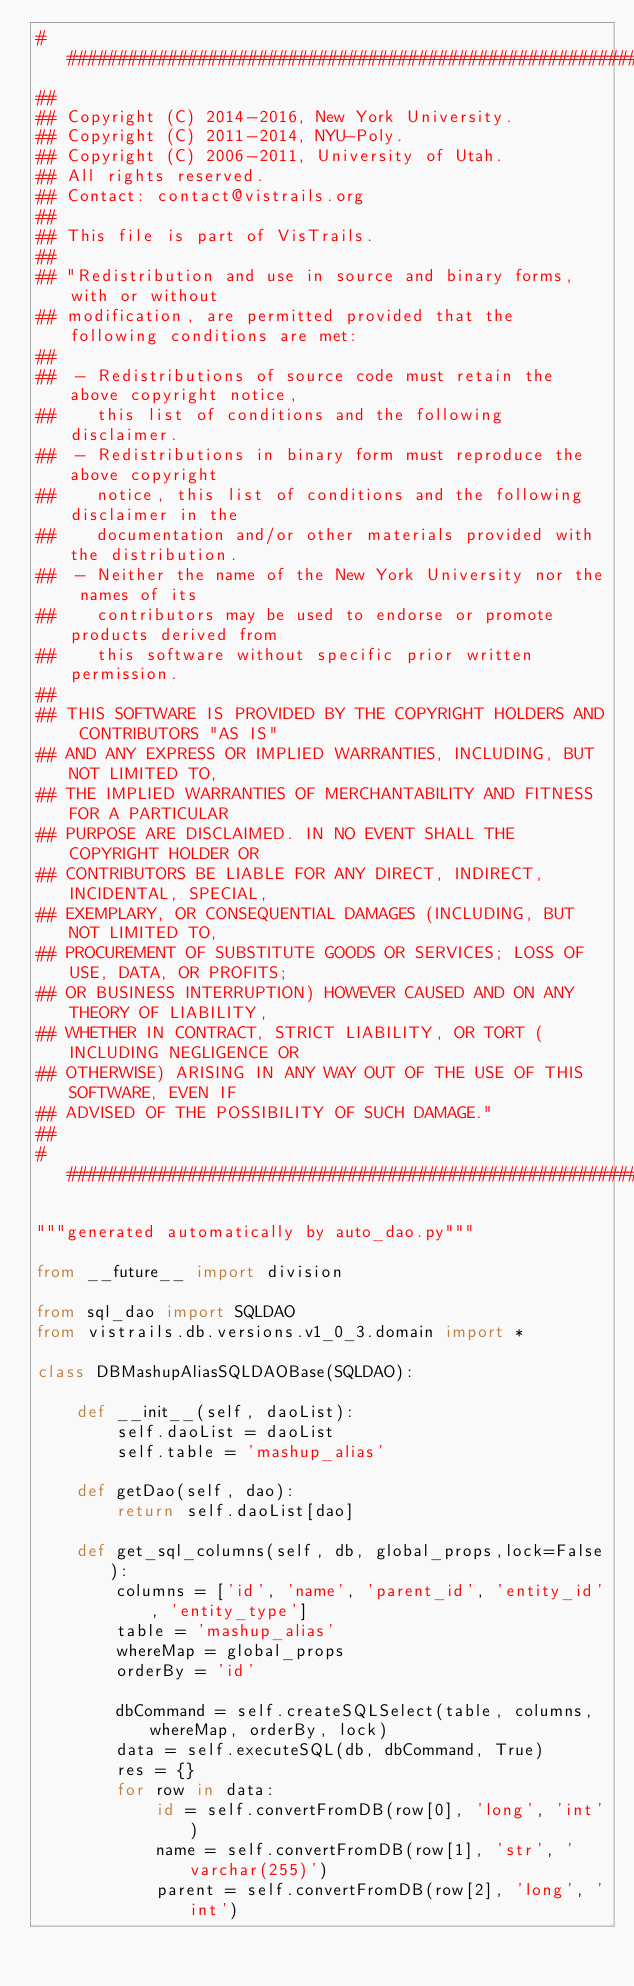<code> <loc_0><loc_0><loc_500><loc_500><_Python_>###############################################################################
##
## Copyright (C) 2014-2016, New York University.
## Copyright (C) 2011-2014, NYU-Poly.
## Copyright (C) 2006-2011, University of Utah.
## All rights reserved.
## Contact: contact@vistrails.org
##
## This file is part of VisTrails.
##
## "Redistribution and use in source and binary forms, with or without
## modification, are permitted provided that the following conditions are met:
##
##  - Redistributions of source code must retain the above copyright notice,
##    this list of conditions and the following disclaimer.
##  - Redistributions in binary form must reproduce the above copyright
##    notice, this list of conditions and the following disclaimer in the
##    documentation and/or other materials provided with the distribution.
##  - Neither the name of the New York University nor the names of its
##    contributors may be used to endorse or promote products derived from
##    this software without specific prior written permission.
##
## THIS SOFTWARE IS PROVIDED BY THE COPYRIGHT HOLDERS AND CONTRIBUTORS "AS IS"
## AND ANY EXPRESS OR IMPLIED WARRANTIES, INCLUDING, BUT NOT LIMITED TO,
## THE IMPLIED WARRANTIES OF MERCHANTABILITY AND FITNESS FOR A PARTICULAR
## PURPOSE ARE DISCLAIMED. IN NO EVENT SHALL THE COPYRIGHT HOLDER OR
## CONTRIBUTORS BE LIABLE FOR ANY DIRECT, INDIRECT, INCIDENTAL, SPECIAL,
## EXEMPLARY, OR CONSEQUENTIAL DAMAGES (INCLUDING, BUT NOT LIMITED TO,
## PROCUREMENT OF SUBSTITUTE GOODS OR SERVICES; LOSS OF USE, DATA, OR PROFITS;
## OR BUSINESS INTERRUPTION) HOWEVER CAUSED AND ON ANY THEORY OF LIABILITY,
## WHETHER IN CONTRACT, STRICT LIABILITY, OR TORT (INCLUDING NEGLIGENCE OR
## OTHERWISE) ARISING IN ANY WAY OUT OF THE USE OF THIS SOFTWARE, EVEN IF
## ADVISED OF THE POSSIBILITY OF SUCH DAMAGE."
##
###############################################################################

"""generated automatically by auto_dao.py"""

from __future__ import division

from sql_dao import SQLDAO
from vistrails.db.versions.v1_0_3.domain import *

class DBMashupAliasSQLDAOBase(SQLDAO):

    def __init__(self, daoList):
        self.daoList = daoList
        self.table = 'mashup_alias'

    def getDao(self, dao):
        return self.daoList[dao]

    def get_sql_columns(self, db, global_props,lock=False):
        columns = ['id', 'name', 'parent_id', 'entity_id', 'entity_type']
        table = 'mashup_alias'
        whereMap = global_props
        orderBy = 'id'

        dbCommand = self.createSQLSelect(table, columns, whereMap, orderBy, lock)
        data = self.executeSQL(db, dbCommand, True)
        res = {}
        for row in data:
            id = self.convertFromDB(row[0], 'long', 'int')
            name = self.convertFromDB(row[1], 'str', 'varchar(255)')
            parent = self.convertFromDB(row[2], 'long', 'int')</code> 